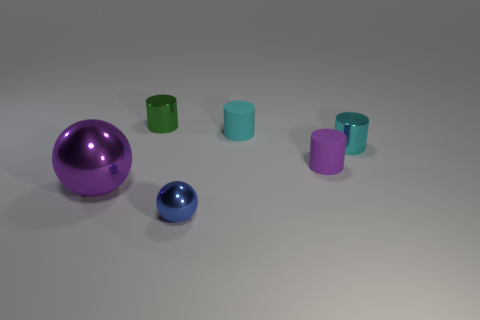Add 3 gray metallic things. How many objects exist? 9 Subtract all tiny purple rubber cylinders. How many cylinders are left? 3 Subtract all cyan cylinders. How many cylinders are left? 2 Subtract all tiny rubber cylinders. Subtract all tiny shiny balls. How many objects are left? 3 Add 1 tiny objects. How many tiny objects are left? 6 Add 4 green shiny cylinders. How many green shiny cylinders exist? 5 Subtract 0 cyan balls. How many objects are left? 6 Subtract all balls. How many objects are left? 4 Subtract 1 cylinders. How many cylinders are left? 3 Subtract all yellow cylinders. Subtract all gray cubes. How many cylinders are left? 4 